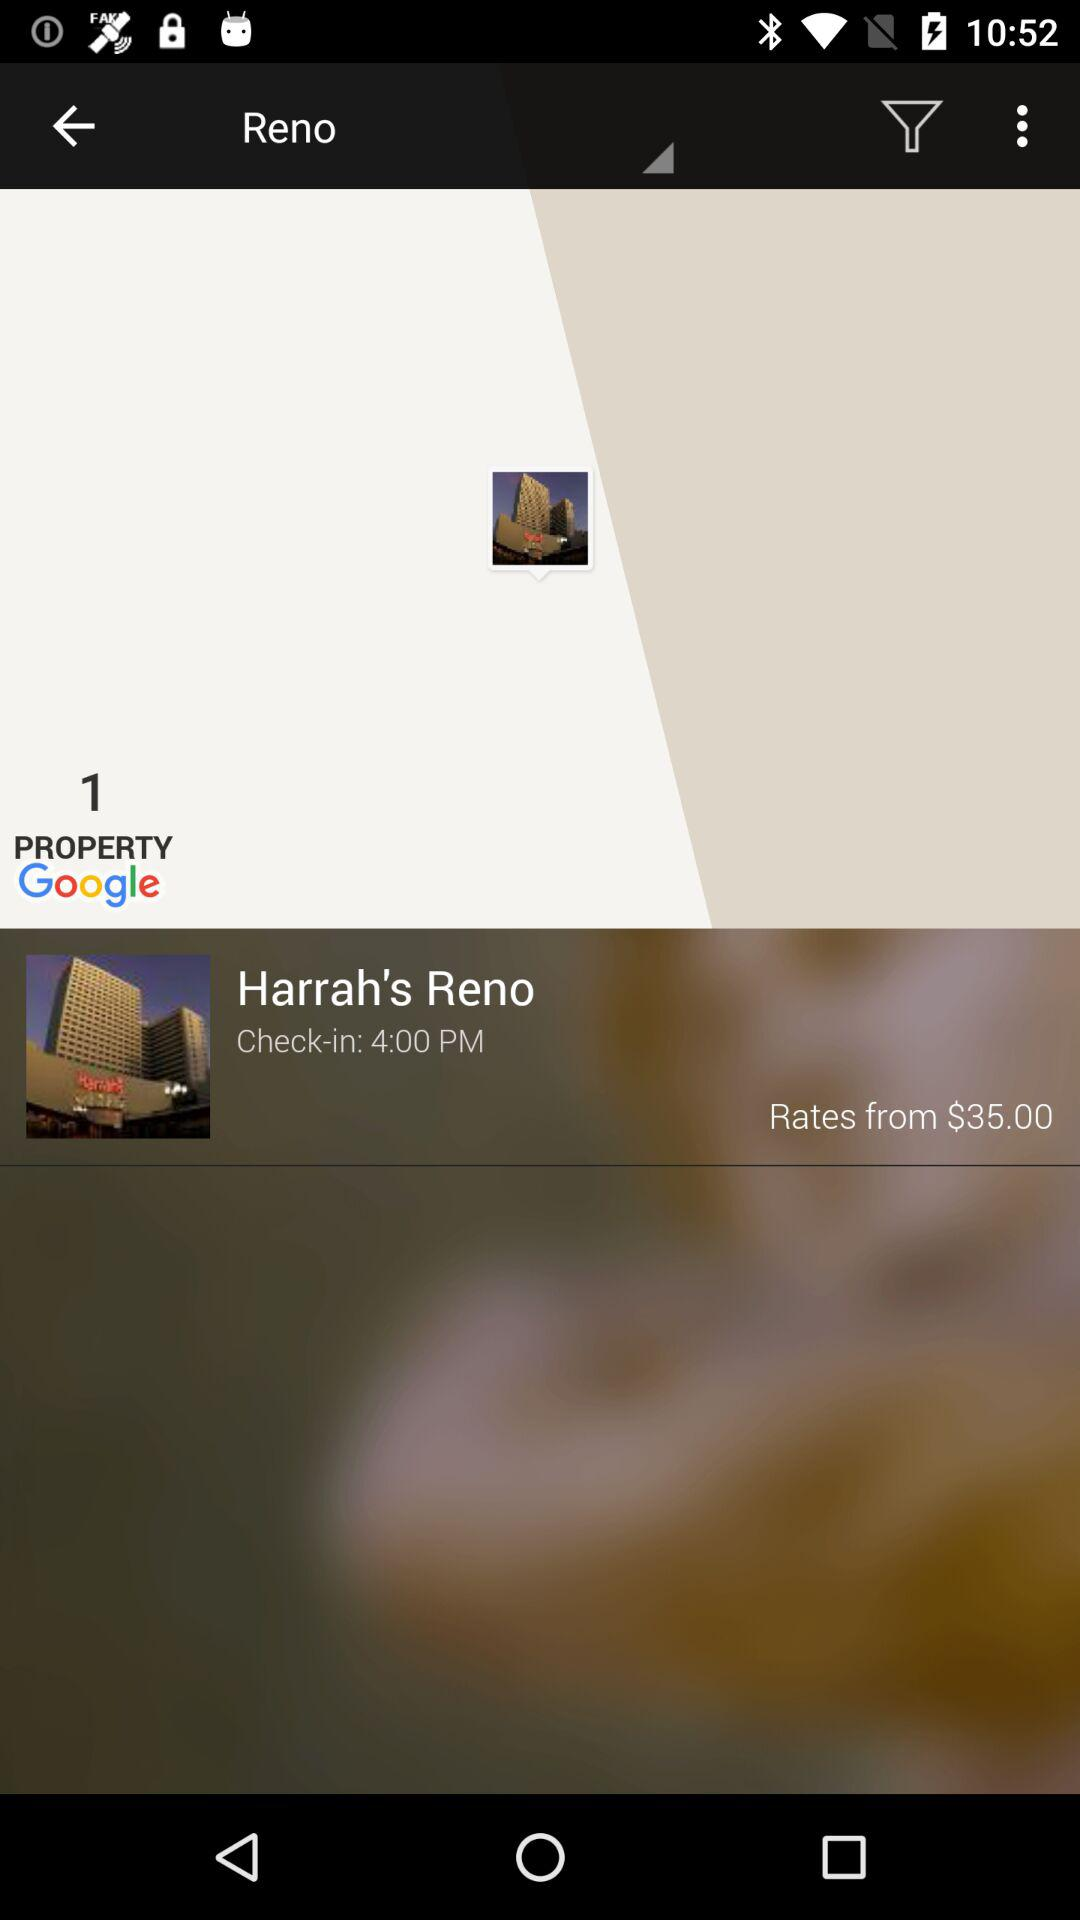What is the hotel name? The hotel name is Harrah's Reno. 